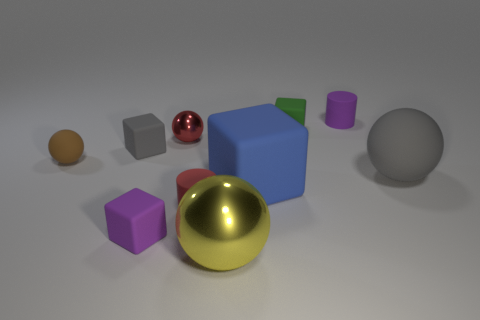What are the different colors of the objects visible in the image? The image features objects in various colors: gold, silver, red, green, blue, purple, and grey. 